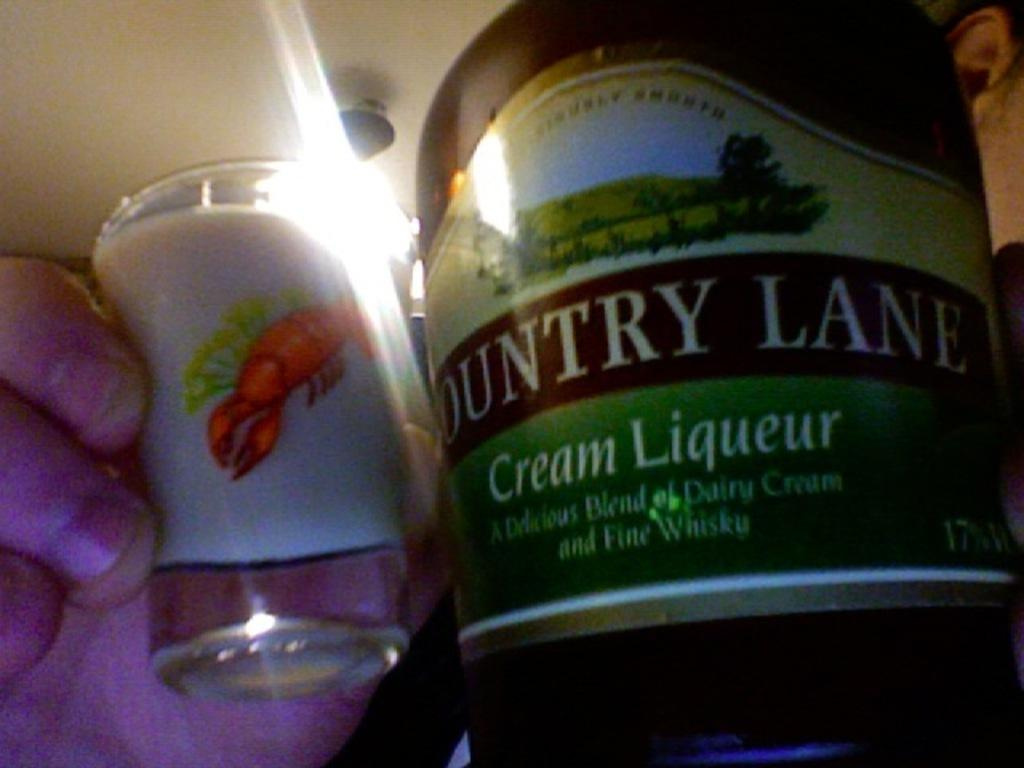Provide a one-sentence caption for the provided image. A man holds a shot of liquer with a bottle showing that it is Country Lane. 